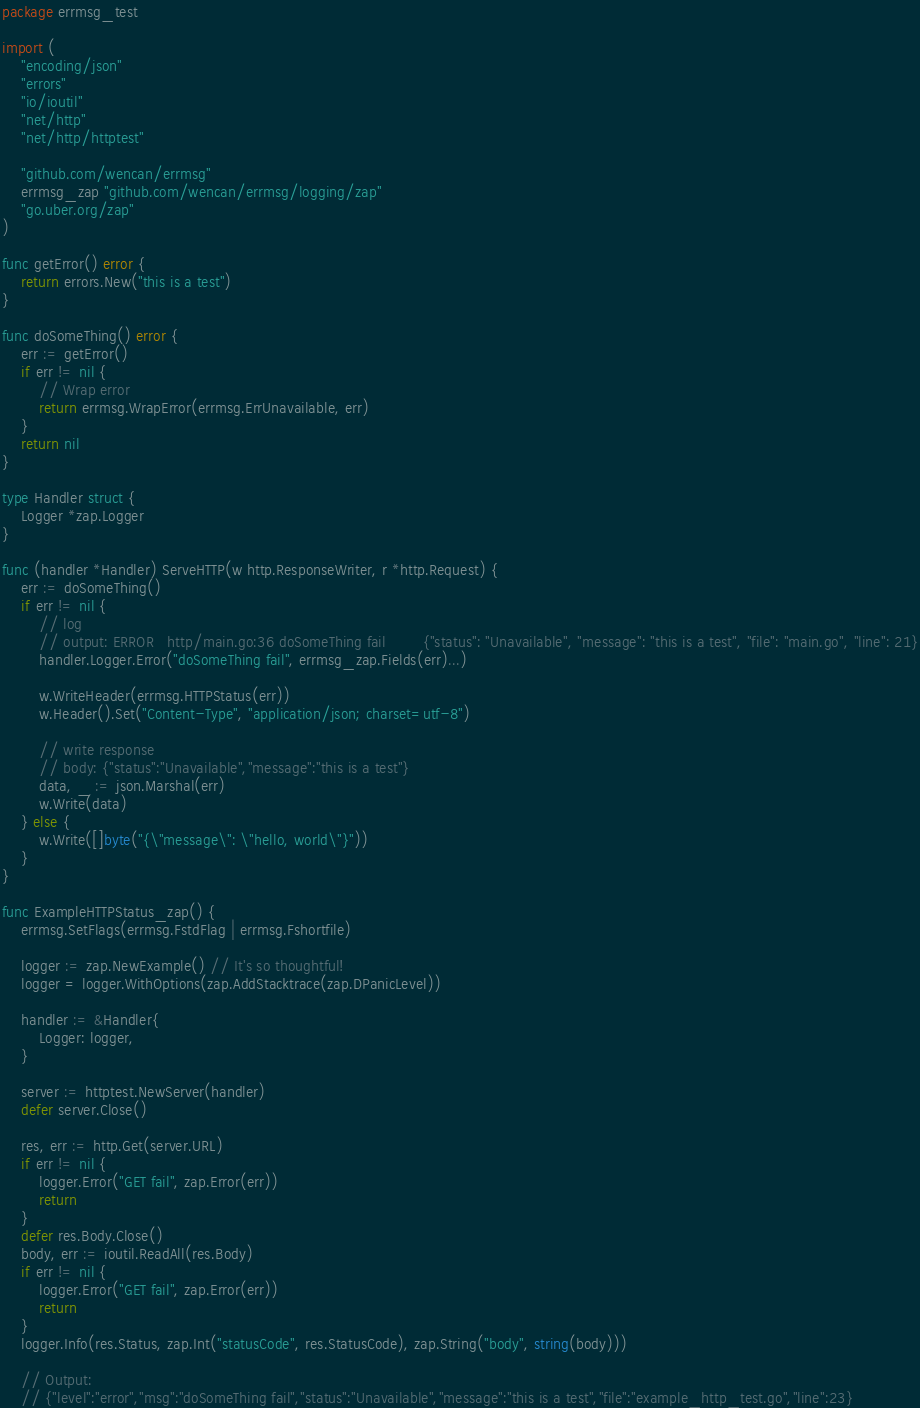<code> <loc_0><loc_0><loc_500><loc_500><_Go_>package errmsg_test

import (
	"encoding/json"
	"errors"
	"io/ioutil"
	"net/http"
	"net/http/httptest"

	"github.com/wencan/errmsg"
	errmsg_zap "github.com/wencan/errmsg/logging/zap"
	"go.uber.org/zap"
)

func getError() error {
	return errors.New("this is a test")
}

func doSomeThing() error {
	err := getError()
	if err != nil {
		// Wrap error
		return errmsg.WrapError(errmsg.ErrUnavailable, err)
	}
	return nil
}

type Handler struct {
	Logger *zap.Logger
}

func (handler *Handler) ServeHTTP(w http.ResponseWriter, r *http.Request) {
	err := doSomeThing()
	if err != nil {
		// log
		// output: ERROR   http/main.go:36 doSomeThing fail        {"status": "Unavailable", "message": "this is a test", "file": "main.go", "line": 21}
		handler.Logger.Error("doSomeThing fail", errmsg_zap.Fields(err)...)

		w.WriteHeader(errmsg.HTTPStatus(err))
		w.Header().Set("Content-Type", "application/json; charset=utf-8")

		// write response
		// body: {"status":"Unavailable","message":"this is a test"}
		data, _ := json.Marshal(err)
		w.Write(data)
	} else {
		w.Write([]byte("{\"message\": \"hello, world\"}"))
	}
}

func ExampleHTTPStatus_zap() {
	errmsg.SetFlags(errmsg.FstdFlag | errmsg.Fshortfile)

	logger := zap.NewExample() // It's so thoughtful!
	logger = logger.WithOptions(zap.AddStacktrace(zap.DPanicLevel))

	handler := &Handler{
		Logger: logger,
	}

	server := httptest.NewServer(handler)
	defer server.Close()

	res, err := http.Get(server.URL)
	if err != nil {
		logger.Error("GET fail", zap.Error(err))
		return
	}
	defer res.Body.Close()
	body, err := ioutil.ReadAll(res.Body)
	if err != nil {
		logger.Error("GET fail", zap.Error(err))
		return
	}
	logger.Info(res.Status, zap.Int("statusCode", res.StatusCode), zap.String("body", string(body)))

	// Output:
	// {"level":"error","msg":"doSomeThing fail","status":"Unavailable","message":"this is a test","file":"example_http_test.go","line":23}</code> 